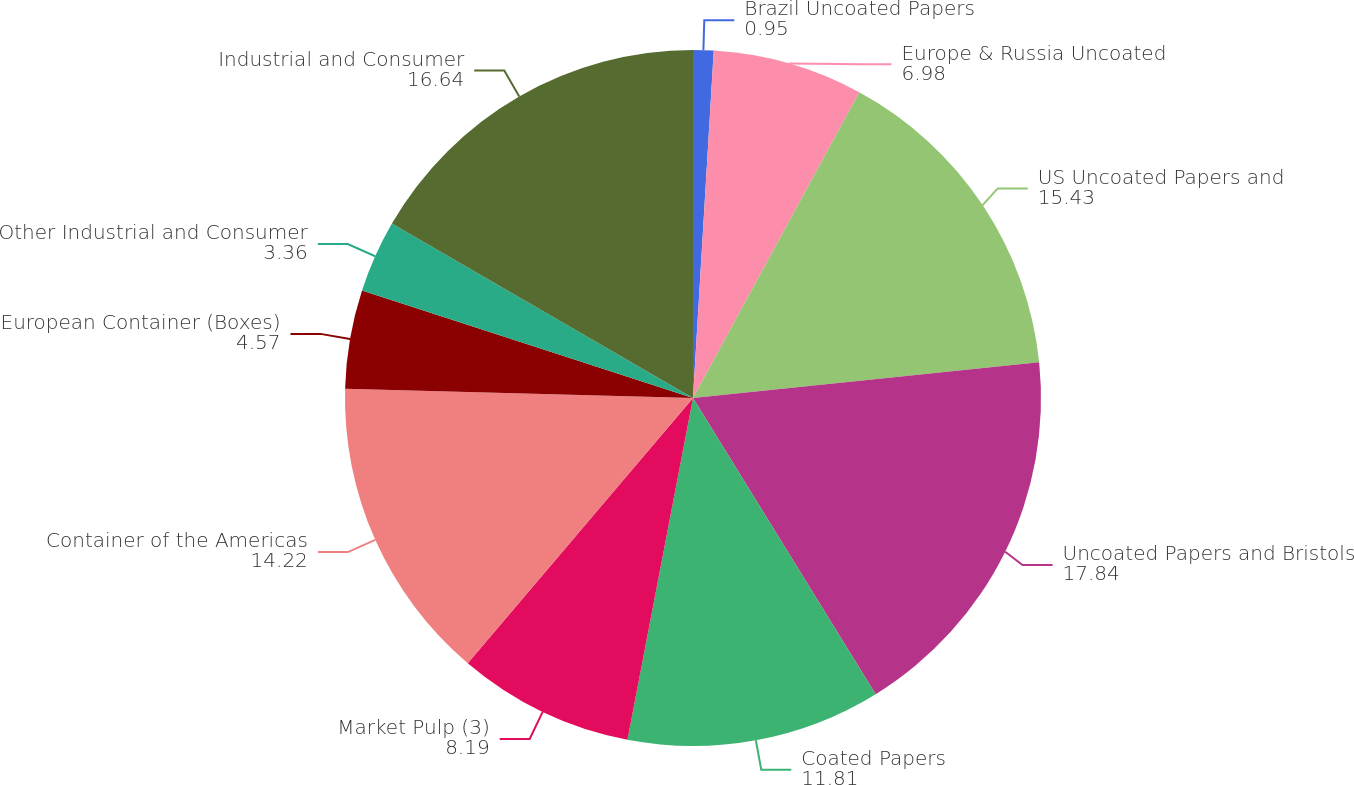<chart> <loc_0><loc_0><loc_500><loc_500><pie_chart><fcel>Brazil Uncoated Papers<fcel>Europe & Russia Uncoated<fcel>US Uncoated Papers and<fcel>Uncoated Papers and Bristols<fcel>Coated Papers<fcel>Market Pulp (3)<fcel>Container of the Americas<fcel>European Container (Boxes)<fcel>Other Industrial and Consumer<fcel>Industrial and Consumer<nl><fcel>0.95%<fcel>6.98%<fcel>15.43%<fcel>17.84%<fcel>11.81%<fcel>8.19%<fcel>14.22%<fcel>4.57%<fcel>3.36%<fcel>16.64%<nl></chart> 